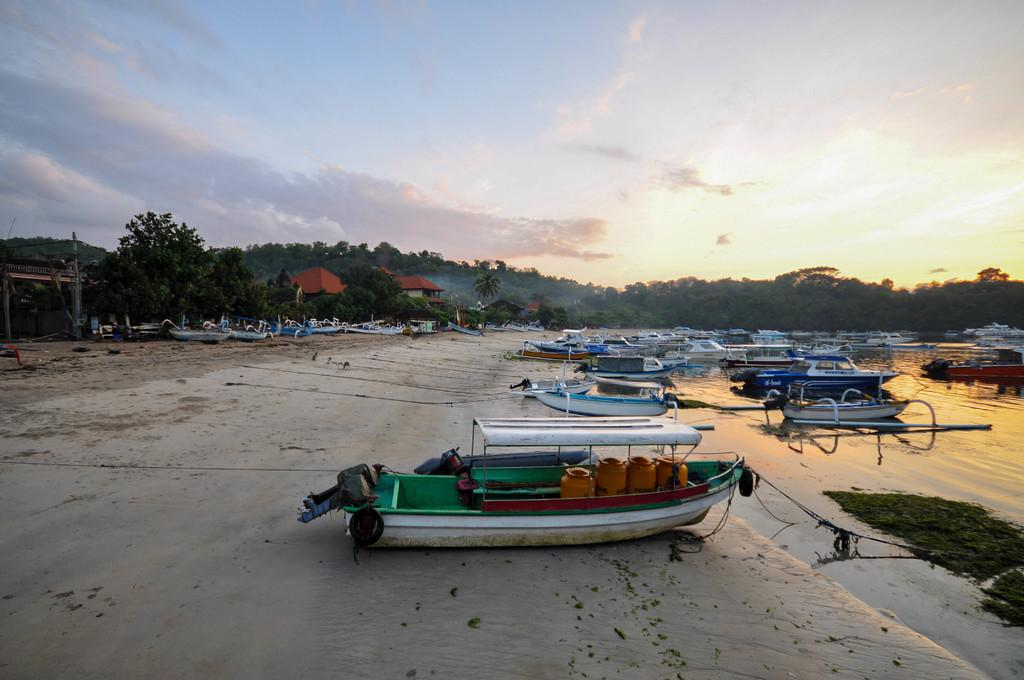What is in the water in the image? There are many boats in the water in the image. What can be seen in the background of the image? Trees and hills are visible in the image. What is the condition of the sky in the image? The sky is cloudy in the image. What are the boats equipped with? There are ropes present in the boats. What type of paper is being used to write the boat's name in the image? There is no paper or writing visible in the image; it only shows boats in the water, trees, hills, and a cloudy sky. 